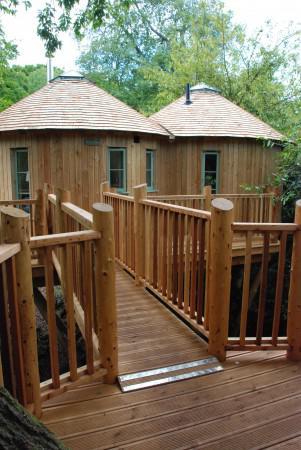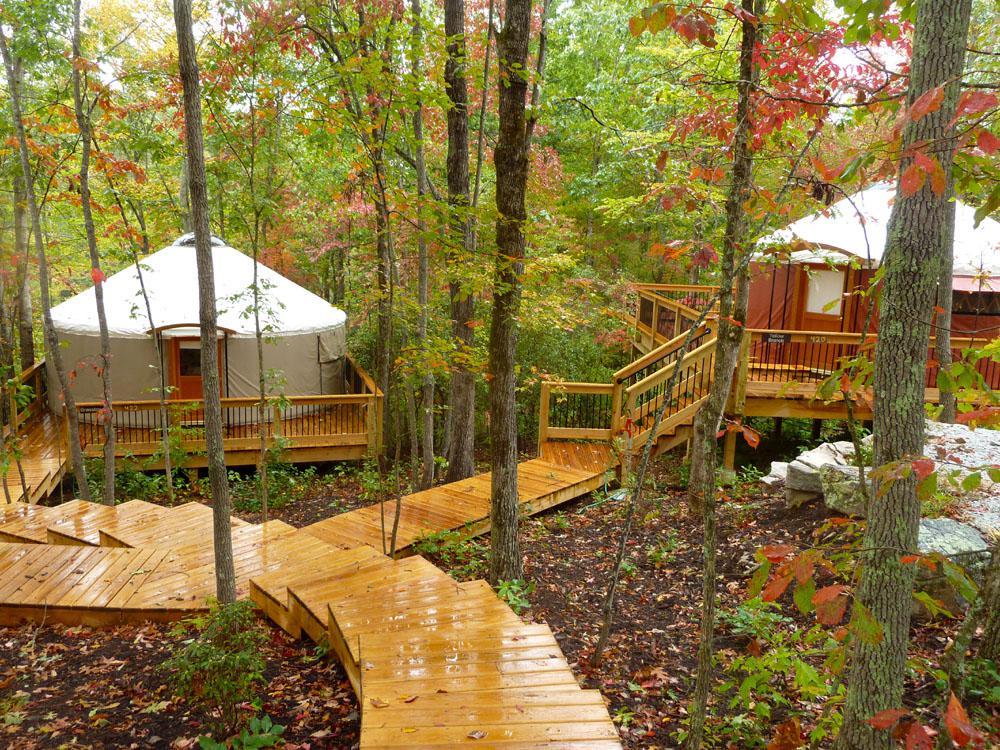The first image is the image on the left, the second image is the image on the right. Examine the images to the left and right. Is the description "At least one image shows a walkway and railing leading to a yurt." accurate? Answer yes or no. Yes. 